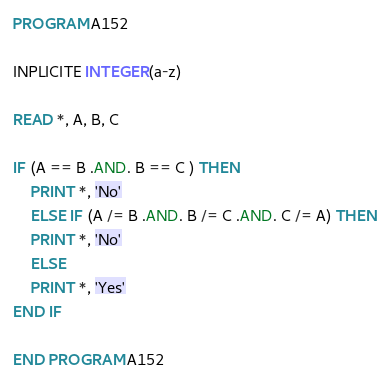<code> <loc_0><loc_0><loc_500><loc_500><_FORTRAN_>PROGRAM A152

INPLICITE INTEGER(a-z)

READ *, A, B, C

IF (A == B .AND. B == C ) THEN
    PRINT *, 'No'
    ELSE IF (A /= B .AND. B /= C .AND. C /= A) THEN
    PRINT *, 'No'
    ELSE
    PRINT *, 'Yes'
END IF

END PROGRAM A152</code> 